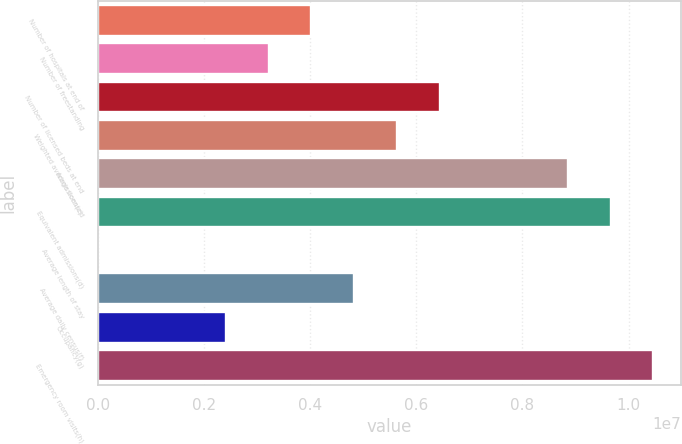Convert chart. <chart><loc_0><loc_0><loc_500><loc_500><bar_chart><fcel>Number of hospitals at end of<fcel>Number of freestanding<fcel>Number of licensed beds at end<fcel>Weighted average licensed<fcel>Admissions(c)<fcel>Equivalent admissions(d)<fcel>Average length of stay<fcel>Average daily census(f)<fcel>Occupancy(g)<fcel>Emergency room visits(h)<nl><fcel>4.02508e+06<fcel>3.22007e+06<fcel>6.44013e+06<fcel>5.63511e+06<fcel>8.85517e+06<fcel>9.66019e+06<fcel>4.9<fcel>4.8301e+06<fcel>2.41505e+06<fcel>1.04652e+07<nl></chart> 